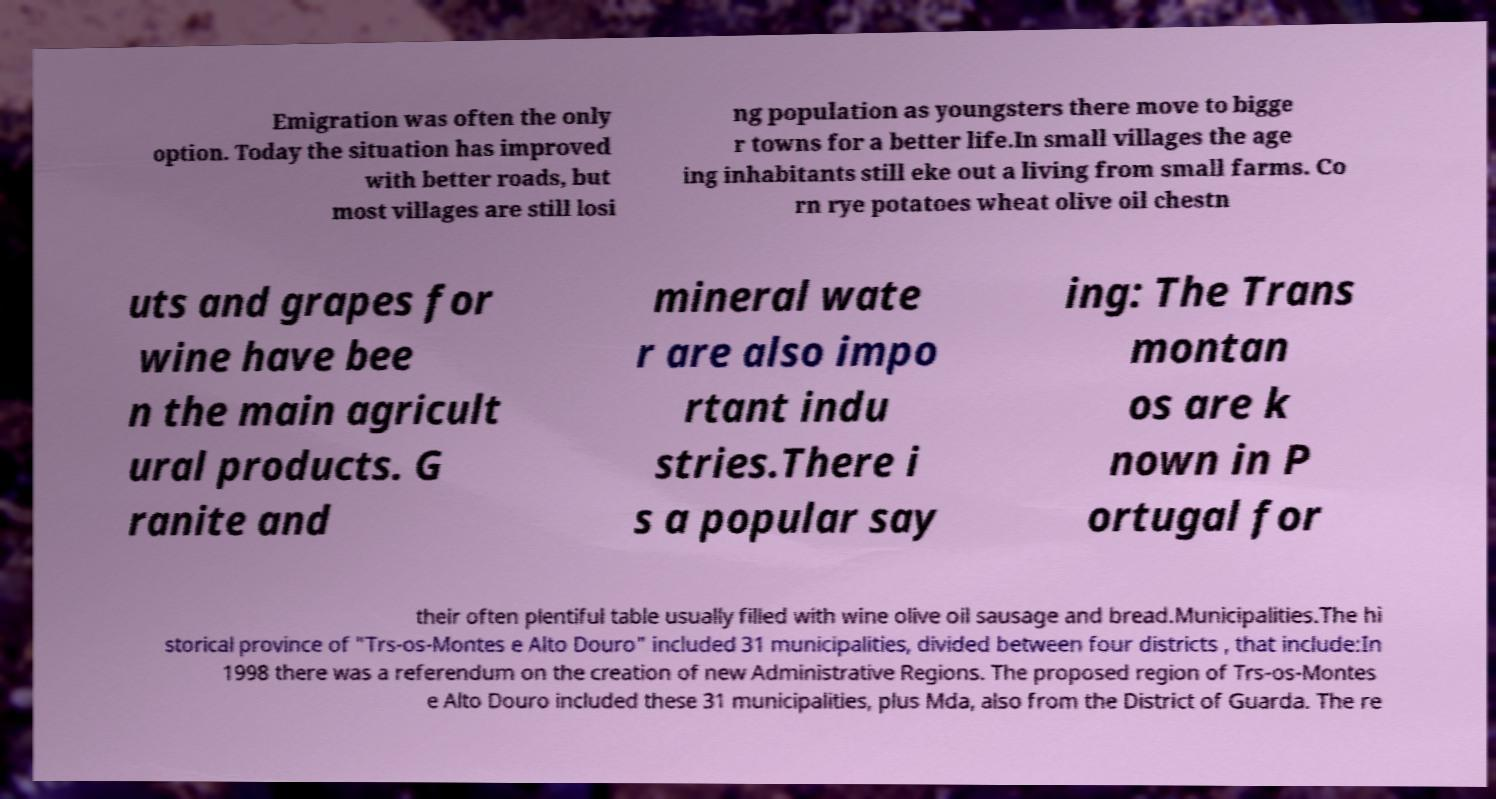Please read and relay the text visible in this image. What does it say? Emigration was often the only option. Today the situation has improved with better roads, but most villages are still losi ng population as youngsters there move to bigge r towns for a better life.In small villages the age ing inhabitants still eke out a living from small farms. Co rn rye potatoes wheat olive oil chestn uts and grapes for wine have bee n the main agricult ural products. G ranite and mineral wate r are also impo rtant indu stries.There i s a popular say ing: The Trans montan os are k nown in P ortugal for their often plentiful table usually filled with wine olive oil sausage and bread.Municipalities.The hi storical province of "Trs-os-Montes e Alto Douro" included 31 municipalities, divided between four districts , that include:In 1998 there was a referendum on the creation of new Administrative Regions. The proposed region of Trs-os-Montes e Alto Douro included these 31 municipalities, plus Mda, also from the District of Guarda. The re 